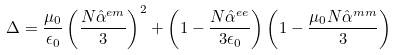Convert formula to latex. <formula><loc_0><loc_0><loc_500><loc_500>\Delta = \frac { \mu _ { 0 } } { \epsilon _ { 0 } } \left ( \frac { N \hat { \alpha } ^ { e m } } { 3 } \right ) ^ { 2 } + \left ( 1 - \frac { N \hat { \alpha } ^ { e e } } { 3 \epsilon _ { 0 } } \right ) \left ( 1 - \frac { \mu _ { 0 } N \hat { \alpha } ^ { m m } } { 3 } \right )</formula> 